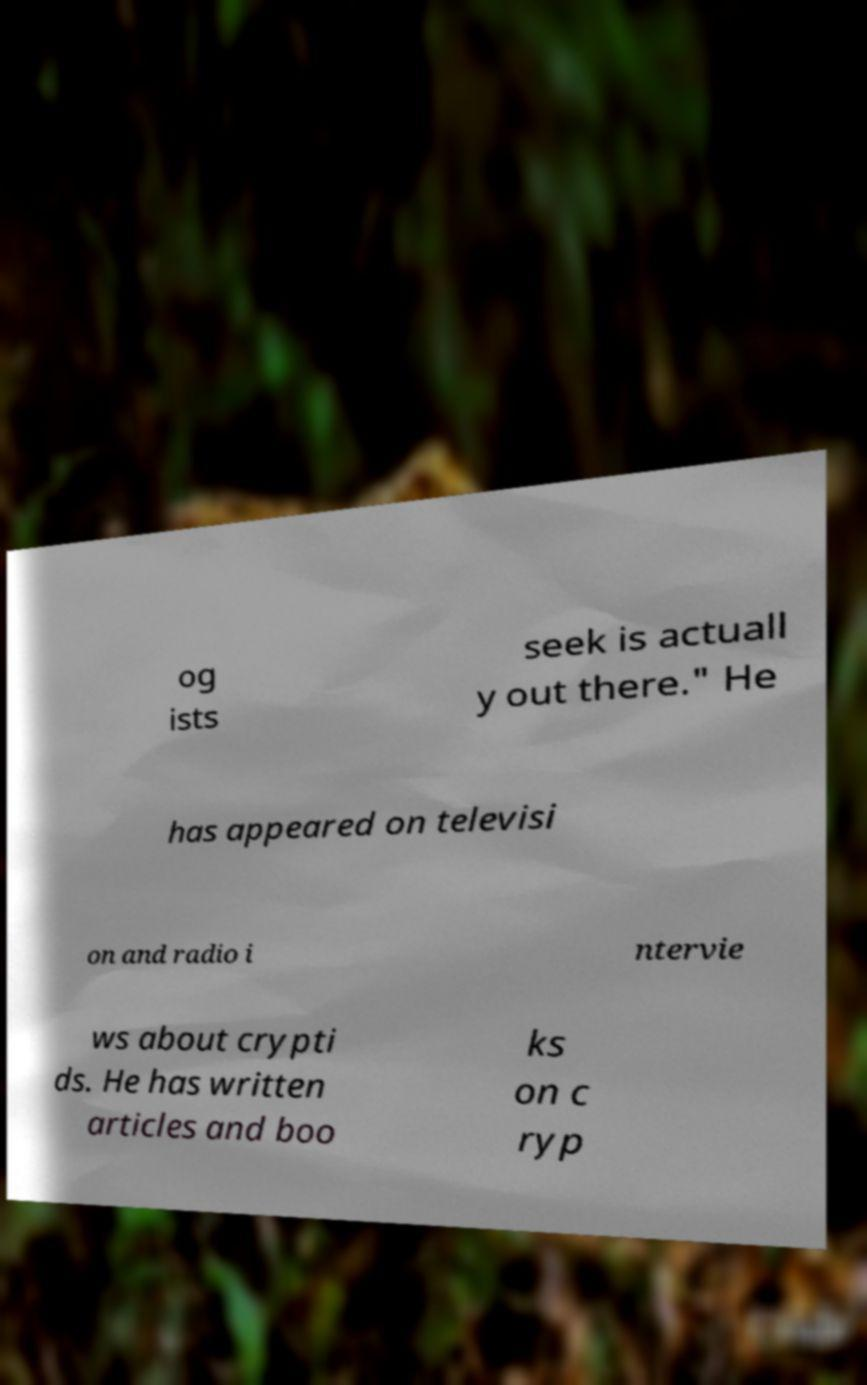Please identify and transcribe the text found in this image. og ists seek is actuall y out there." He has appeared on televisi on and radio i ntervie ws about crypti ds. He has written articles and boo ks on c ryp 